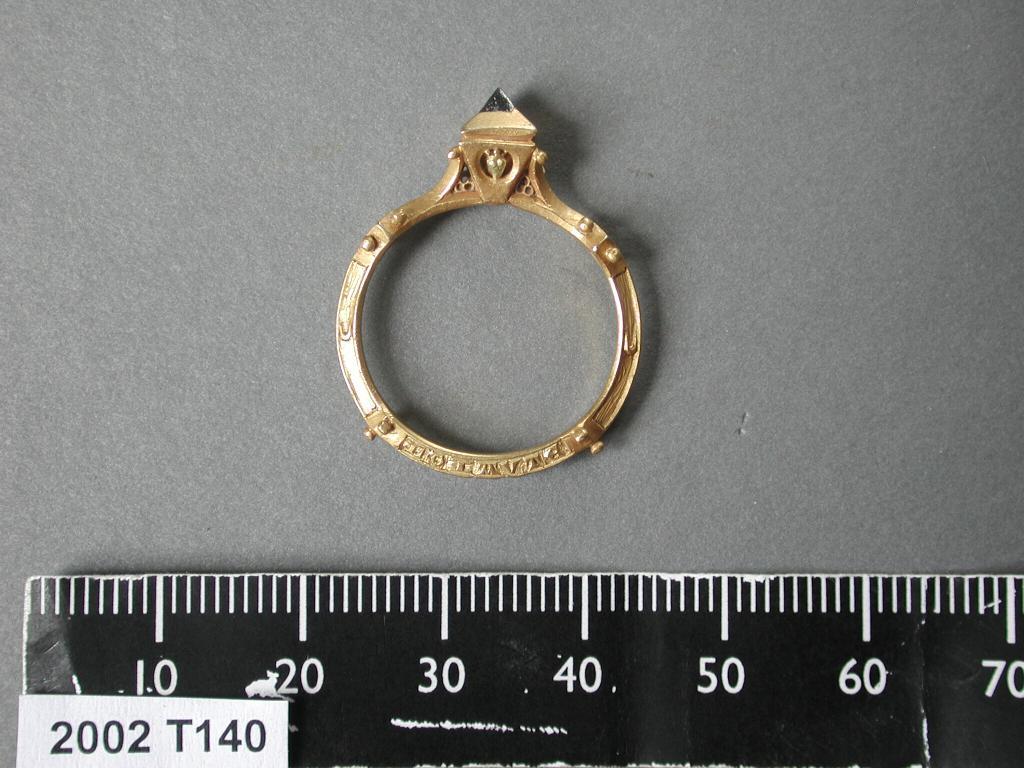What year is this?
Offer a very short reply. 2002. 